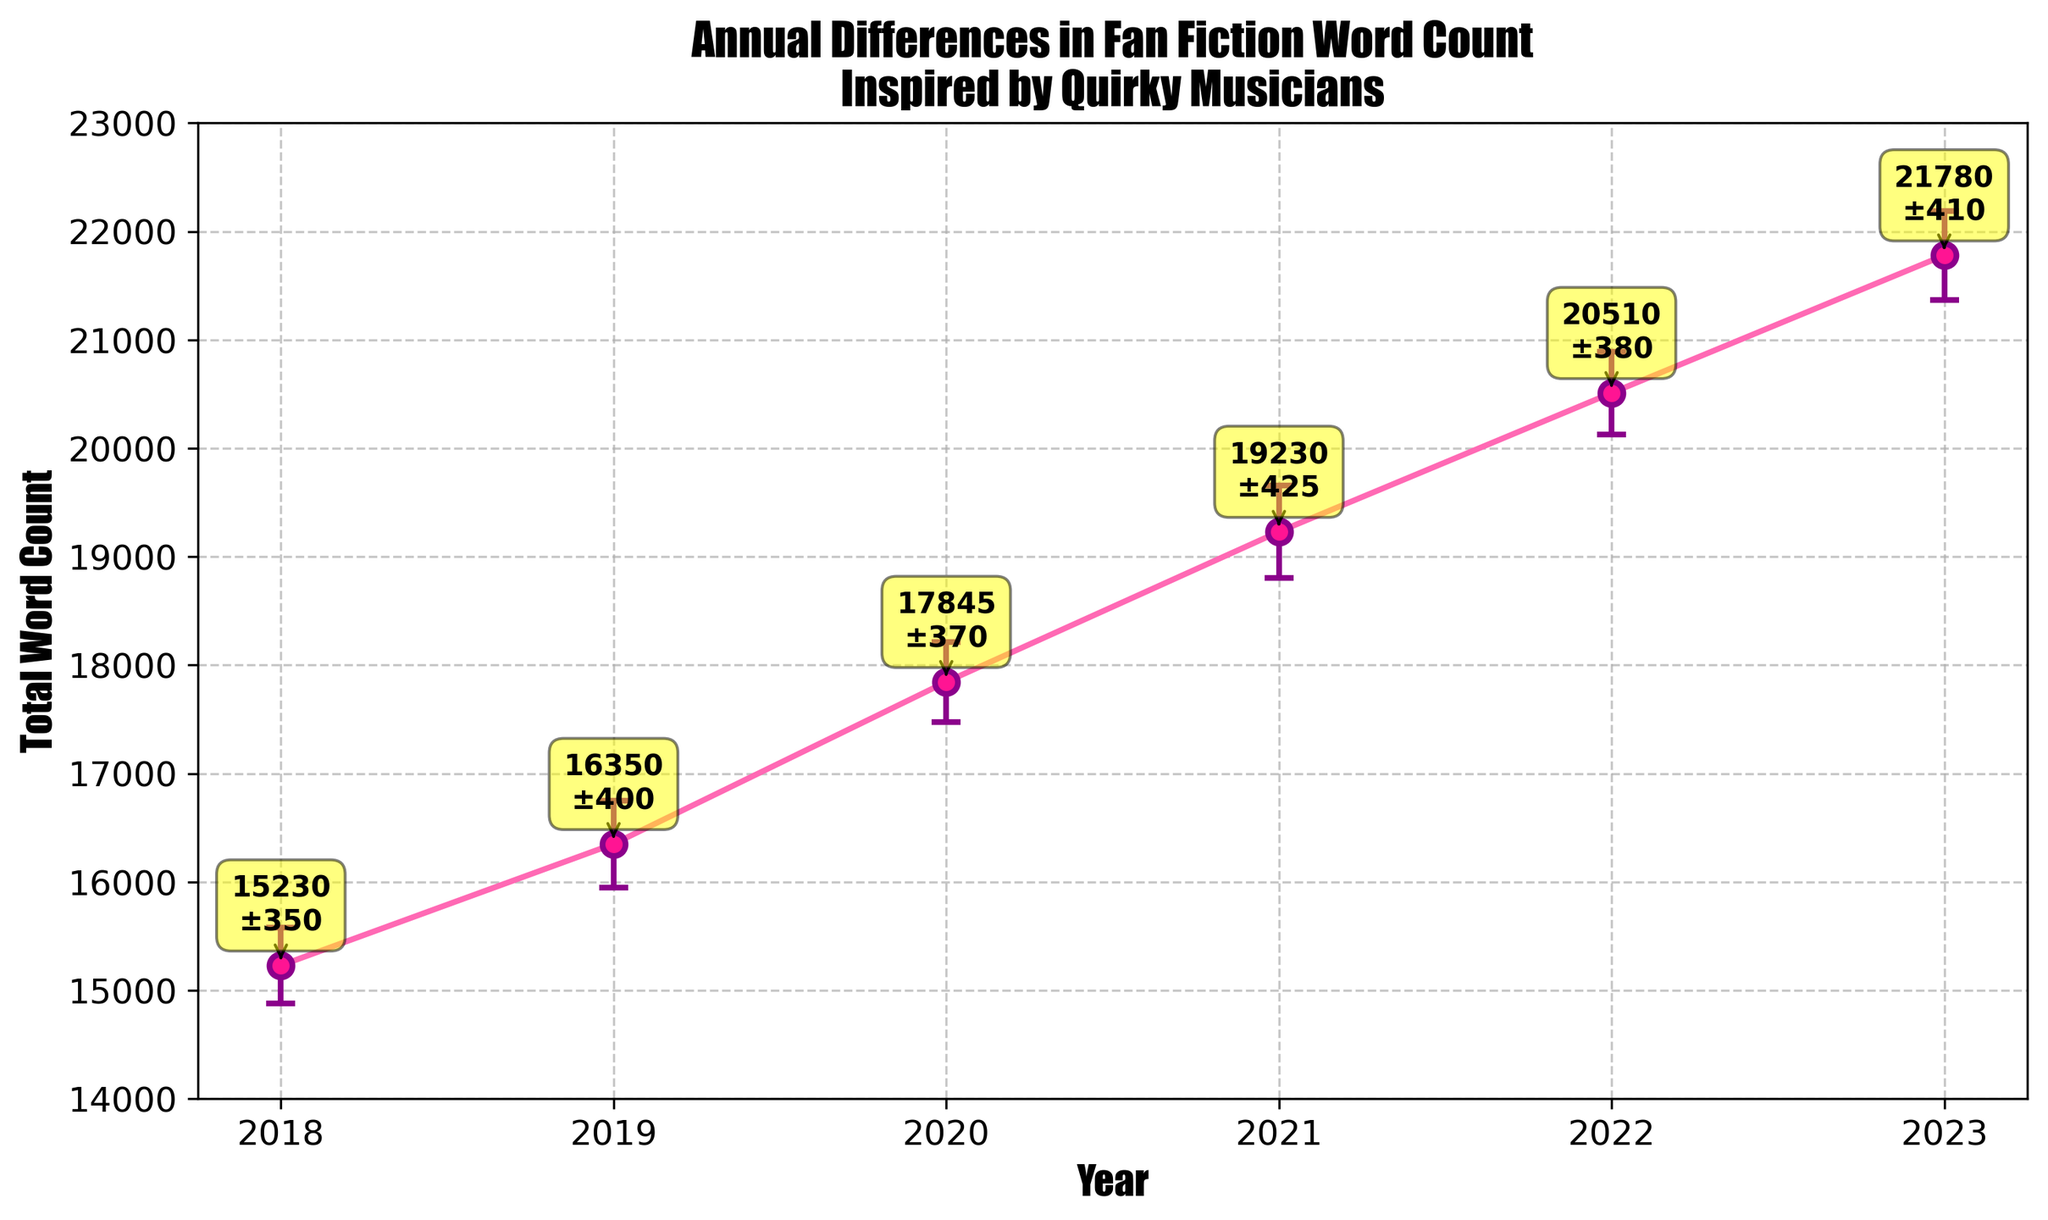What is the title of the figure? The title of the figure is displayed at the top of the plot and often describes the overall content of the plot. Here it is "Annual Differences in Fan Fiction Word Count Inspired by Quirky Musicians."
Answer: Annual Differences in Fan Fiction Word Count Inspired by Quirky Musicians What are the years shown on the x-axis? The x-axis represents the "Year" and lists several specific years. From the plot, we can see the years are 2018, 2019, 2020, 2021, 2022, and 2023.
Answer: 2018, 2019, 2020, 2021, 2022, 2023 What is the total word count in 2021? The plot shows the total word counts for each year and their respective error bars. For 2021, it is indicated as 19,230 words.
Answer: 19,230 Which year has the highest total word count? The plot shows the total word counts for each year. Among the listed years, 2023 has the highest total word count at 21,780 words.
Answer: 2023 What is the average total word count over all these years? To find the average, sum all total word counts for the years and divide by the number of years. The total is (15,230 + 16,350 + 17,845 + 19,230 + 20,510 + 21,780) = 110,945. There are 6 years, so the average is 110,945 / 6.
Answer: 18,491 How does the total word count in 2019 compare to 2020? To compare, look at the word counts for 2019 and 2020. 2019 had 16,350 words, and 2020 had 17,845 words. 2020 had a higher word count.
Answer: 2020 had a higher word count What is the range of word counts displayed in the figure? The range of word counts is the difference between the maximum and minimum word counts. The maximum is in 2023 with 21,780 words, and the minimum is in 2018 with 15,230 words. The range is 21,780 - 15,230.
Answer: 6,550 Which year has the largest error bar, and what is its value? The plot shows error bars for each year. The largest error bar appears in 2021 with a value of 425.
Answer: 2021 with 425 What is the increase in total word count from 2018 to 2023? To find the increase, subtract the total word count in 2018 from that in 2023. In 2018, it was 15,230 words, and in 2023, it was 21,780 words, so the increase is 21,780 - 15,230.
Answer: 6,550 What is the total error from summing all the error bars across the years? Sum the error values for each year: 350 (2018) + 400 (2019) + 370 (2020) + 425 (2021) + 380 (2022) + 410 (2023).
Answer: 2,335 